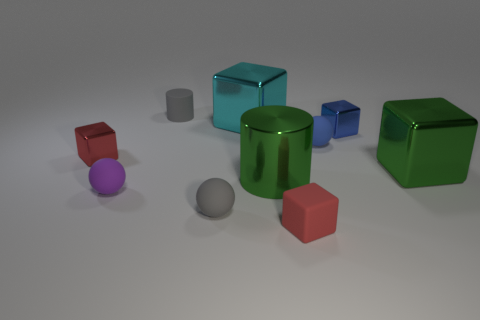What is the size of the rubber thing that is the same color as the small matte cylinder?
Offer a very short reply. Small. There is a cylinder that is made of the same material as the cyan block; what size is it?
Ensure brevity in your answer.  Large. How many other shiny things have the same shape as the tiny blue shiny object?
Offer a very short reply. 3. Do the tiny blue cube and the large cube on the left side of the metallic cylinder have the same material?
Your response must be concise. Yes. Are there more small red blocks that are behind the tiny purple rubber thing than big blue spheres?
Your answer should be compact. Yes. The shiny object that is the same color as the large shiny cylinder is what shape?
Keep it short and to the point. Cube. Are there any gray cylinders made of the same material as the small blue sphere?
Keep it short and to the point. Yes. Do the red block on the left side of the cyan cube and the blue thing that is behind the small blue matte thing have the same material?
Your answer should be very brief. Yes. Are there the same number of objects that are behind the green cube and tiny things to the right of the tiny purple object?
Provide a short and direct response. Yes. What is the color of the matte cube that is the same size as the purple matte thing?
Keep it short and to the point. Red. 